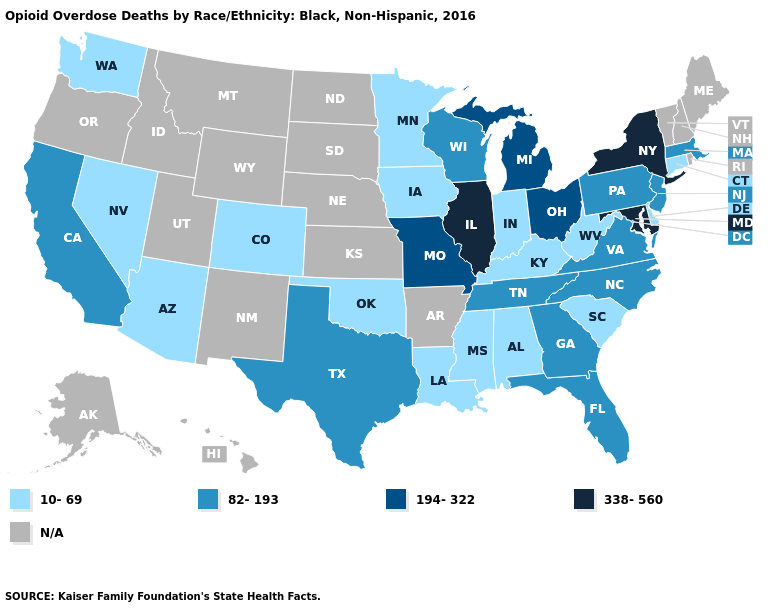Name the states that have a value in the range N/A?
Give a very brief answer. Alaska, Arkansas, Hawaii, Idaho, Kansas, Maine, Montana, Nebraska, New Hampshire, New Mexico, North Dakota, Oregon, Rhode Island, South Dakota, Utah, Vermont, Wyoming. Name the states that have a value in the range 82-193?
Answer briefly. California, Florida, Georgia, Massachusetts, New Jersey, North Carolina, Pennsylvania, Tennessee, Texas, Virginia, Wisconsin. Name the states that have a value in the range 82-193?
Answer briefly. California, Florida, Georgia, Massachusetts, New Jersey, North Carolina, Pennsylvania, Tennessee, Texas, Virginia, Wisconsin. What is the value of Delaware?
Be succinct. 10-69. Does the first symbol in the legend represent the smallest category?
Concise answer only. Yes. Name the states that have a value in the range 10-69?
Write a very short answer. Alabama, Arizona, Colorado, Connecticut, Delaware, Indiana, Iowa, Kentucky, Louisiana, Minnesota, Mississippi, Nevada, Oklahoma, South Carolina, Washington, West Virginia. Does California have the highest value in the West?
Keep it brief. Yes. Does the first symbol in the legend represent the smallest category?
Keep it brief. Yes. What is the value of North Dakota?
Write a very short answer. N/A. Is the legend a continuous bar?
Write a very short answer. No. How many symbols are there in the legend?
Write a very short answer. 5. What is the value of Mississippi?
Give a very brief answer. 10-69. 